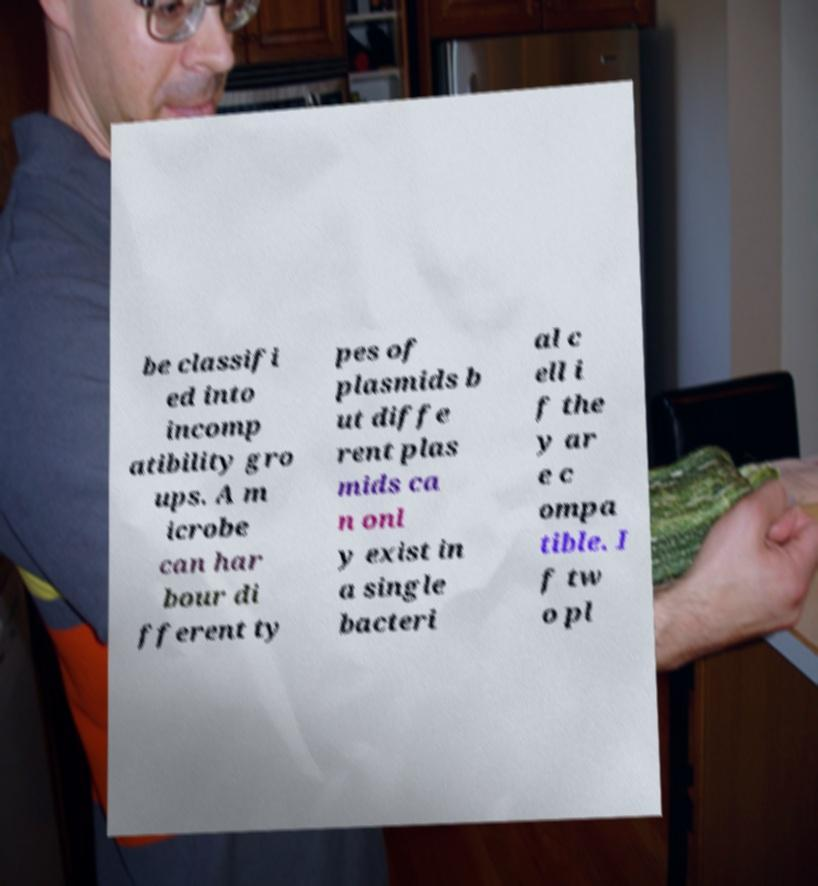What messages or text are displayed in this image? I need them in a readable, typed format. be classifi ed into incomp atibility gro ups. A m icrobe can har bour di fferent ty pes of plasmids b ut diffe rent plas mids ca n onl y exist in a single bacteri al c ell i f the y ar e c ompa tible. I f tw o pl 